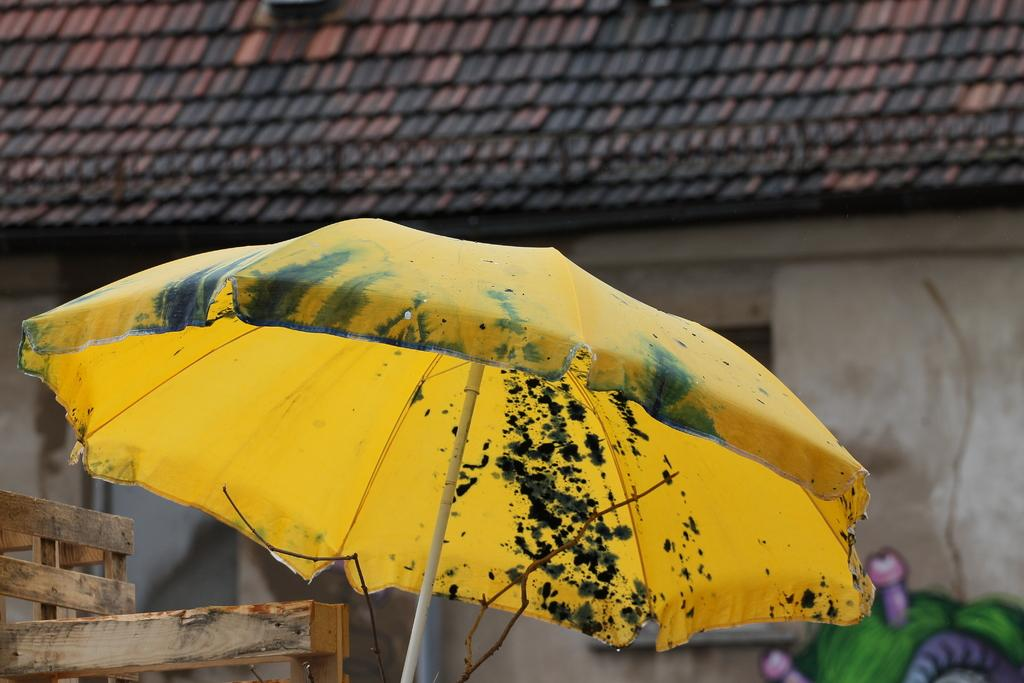What object is visible in the image that provides protection from the rain? There is an umbrella in the image. What type of material is used for the objects at the bottom of the image? The objects at the bottom of the image are made of wood. What can be seen in the distance behind the wooden objects? There is a house in the background of the image. What type of roof does the house have? The house has a gable roof. How does the dad in the image perform the operation on the quiet patient? There is no dad or operation present in the image; it only features an umbrella, wooden objects, a house, and an object at the bottom. 